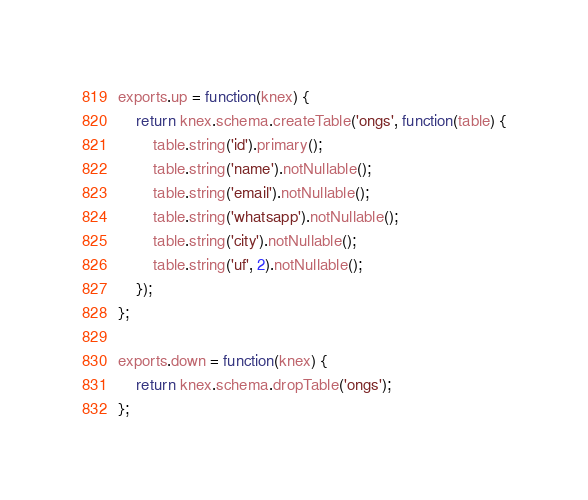Convert code to text. <code><loc_0><loc_0><loc_500><loc_500><_JavaScript_>exports.up = function(knex) {  
    return knex.schema.createTable('ongs', function(table) {
        table.string('id').primary();
        table.string('name').notNullable();
        table.string('email').notNullable();
        table.string('whatsapp').notNullable();
        table.string('city').notNullable();
        table.string('uf', 2).notNullable();
    });
};

exports.down = function(knex) {
    return knex.schema.dropTable('ongs');
};
</code> 